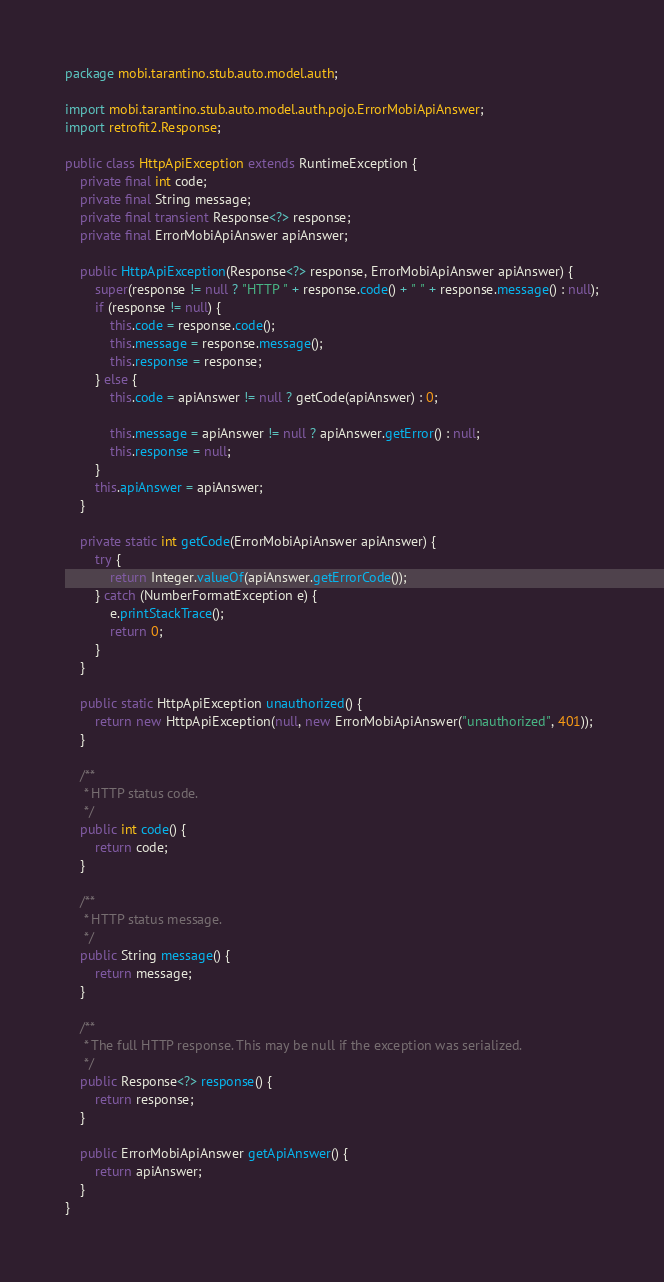Convert code to text. <code><loc_0><loc_0><loc_500><loc_500><_Java_>package mobi.tarantino.stub.auto.model.auth;

import mobi.tarantino.stub.auto.model.auth.pojo.ErrorMobiApiAnswer;
import retrofit2.Response;

public class HttpApiException extends RuntimeException {
    private final int code;
    private final String message;
    private final transient Response<?> response;
    private final ErrorMobiApiAnswer apiAnswer;

    public HttpApiException(Response<?> response, ErrorMobiApiAnswer apiAnswer) {
        super(response != null ? "HTTP " + response.code() + " " + response.message() : null);
        if (response != null) {
            this.code = response.code();
            this.message = response.message();
            this.response = response;
        } else {
            this.code = apiAnswer != null ? getCode(apiAnswer) : 0;

            this.message = apiAnswer != null ? apiAnswer.getError() : null;
            this.response = null;
        }
        this.apiAnswer = apiAnswer;
    }

    private static int getCode(ErrorMobiApiAnswer apiAnswer) {
        try {
            return Integer.valueOf(apiAnswer.getErrorCode());
        } catch (NumberFormatException e) {
            e.printStackTrace();
            return 0;
        }
    }

    public static HttpApiException unauthorized() {
        return new HttpApiException(null, new ErrorMobiApiAnswer("unauthorized", 401));
    }

    /**
     * HTTP status code.
     */
    public int code() {
        return code;
    }

    /**
     * HTTP status message.
     */
    public String message() {
        return message;
    }

    /**
     * The full HTTP response. This may be null if the exception was serialized.
     */
    public Response<?> response() {
        return response;
    }

    public ErrorMobiApiAnswer getApiAnswer() {
        return apiAnswer;
    }
}
</code> 